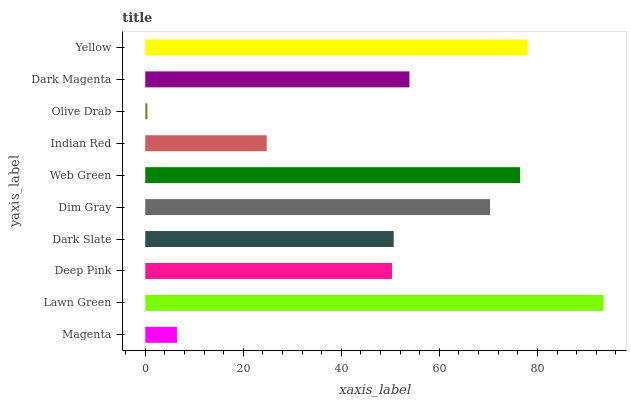Is Olive Drab the minimum?
Answer yes or no. Yes. Is Lawn Green the maximum?
Answer yes or no. Yes. Is Deep Pink the minimum?
Answer yes or no. No. Is Deep Pink the maximum?
Answer yes or no. No. Is Lawn Green greater than Deep Pink?
Answer yes or no. Yes. Is Deep Pink less than Lawn Green?
Answer yes or no. Yes. Is Deep Pink greater than Lawn Green?
Answer yes or no. No. Is Lawn Green less than Deep Pink?
Answer yes or no. No. Is Dark Magenta the high median?
Answer yes or no. Yes. Is Dark Slate the low median?
Answer yes or no. Yes. Is Lawn Green the high median?
Answer yes or no. No. Is Indian Red the low median?
Answer yes or no. No. 